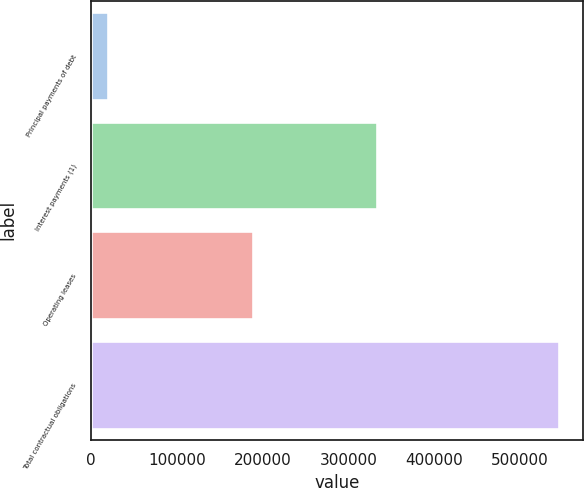Convert chart to OTSL. <chart><loc_0><loc_0><loc_500><loc_500><bar_chart><fcel>Principal payments of debt<fcel>Interest payments (1)<fcel>Operating leases<fcel>Total contractual obligations<nl><fcel>20000<fcel>333741<fcel>188382<fcel>545842<nl></chart> 